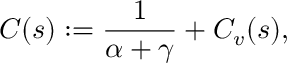Convert formula to latex. <formula><loc_0><loc_0><loc_500><loc_500>C ( s ) \colon = \frac { 1 } { \alpha + \gamma } + C _ { v } ( s ) ,</formula> 